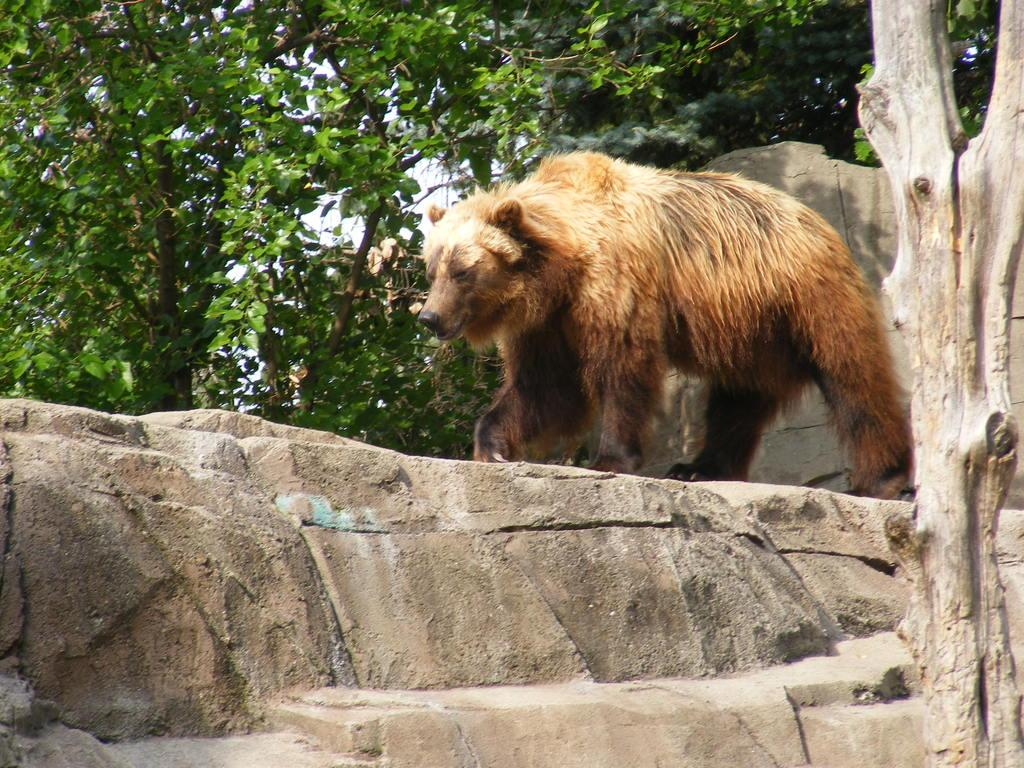What animal is present in the image? There is a bear in the image. What is the bear doing in the image? The bear is walking on a rock. What can be seen on the right side of the image? There is a tree trunk on the right side of the image. What type of vegetation is visible in the background of the image? There are trees visible in the background of the image. How many times does the bear use the calculator in the image? There is no calculator present in the image, so the bear cannot use it. 